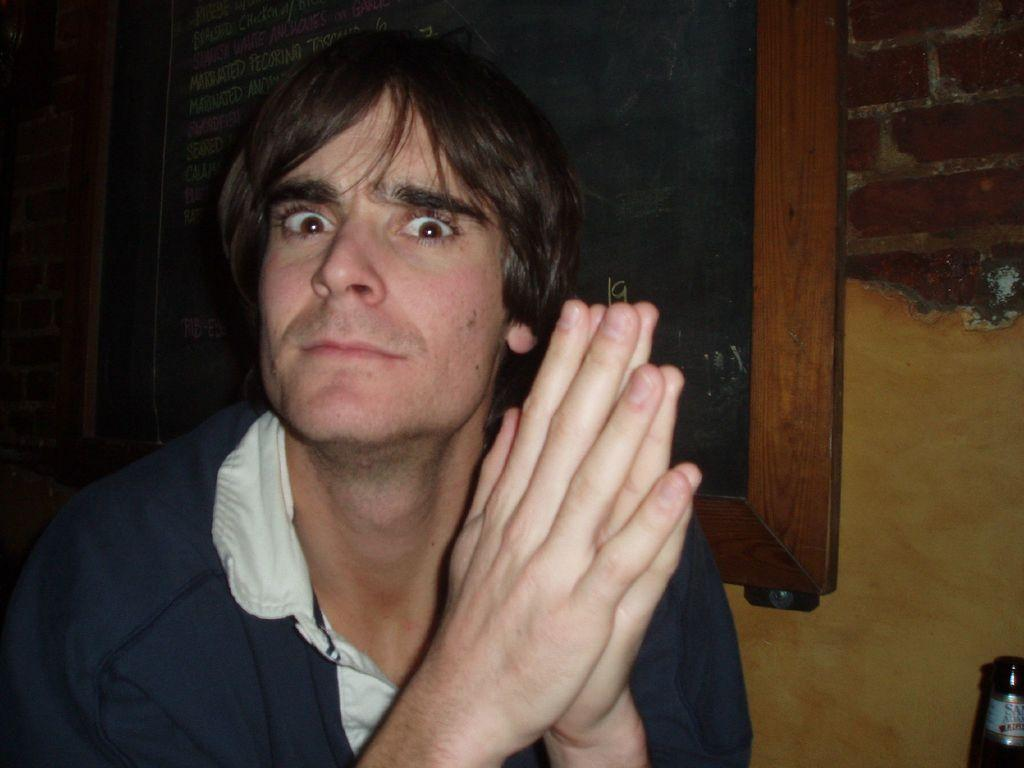Who is the main subject in the foreground of the image? There is a man in the foreground of the image. What can be seen in the background of the image? There is a blackboard and a wall in the background of the image. Where is the bottle located in the image? The bottle is in the right bottom corner of the image. What type of organization is responsible for the debt shown on the blackboard in the image? There is no mention of debt or any organization in the image; it only features a man, a blackboard, a wall, and a bottle. 